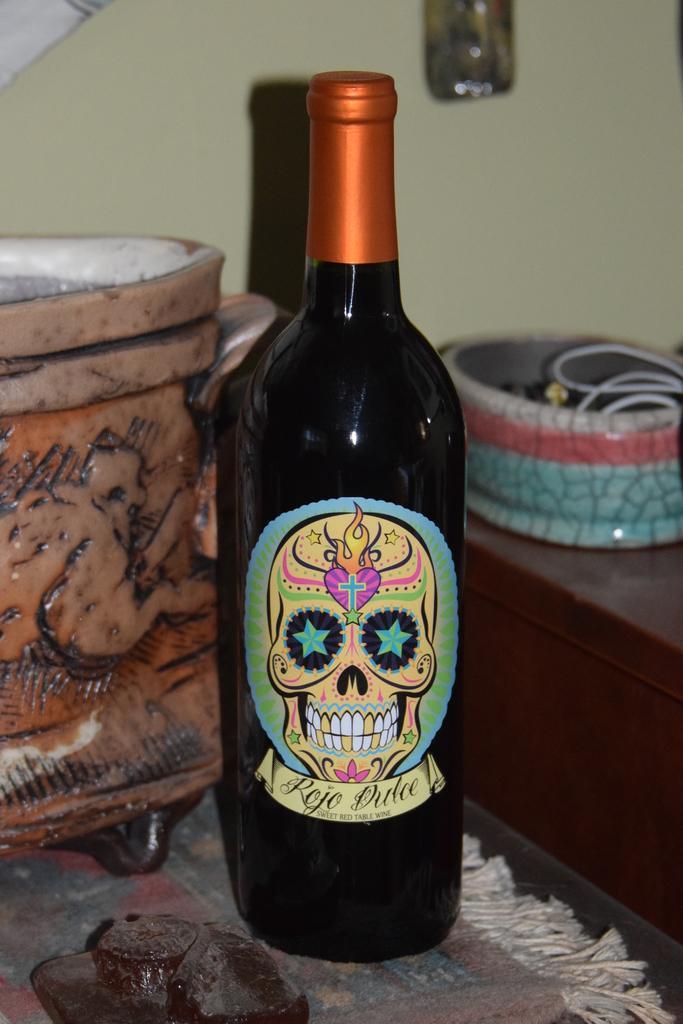Can you describe this image briefly? This picture seems to be clicked inside the room. In the center we can see a black color glass bottle placed on the table and we can see some other objects are placed on the top of the tables. In the background we can see the wall and some other objects and we can see the picture of a skull and the text. 